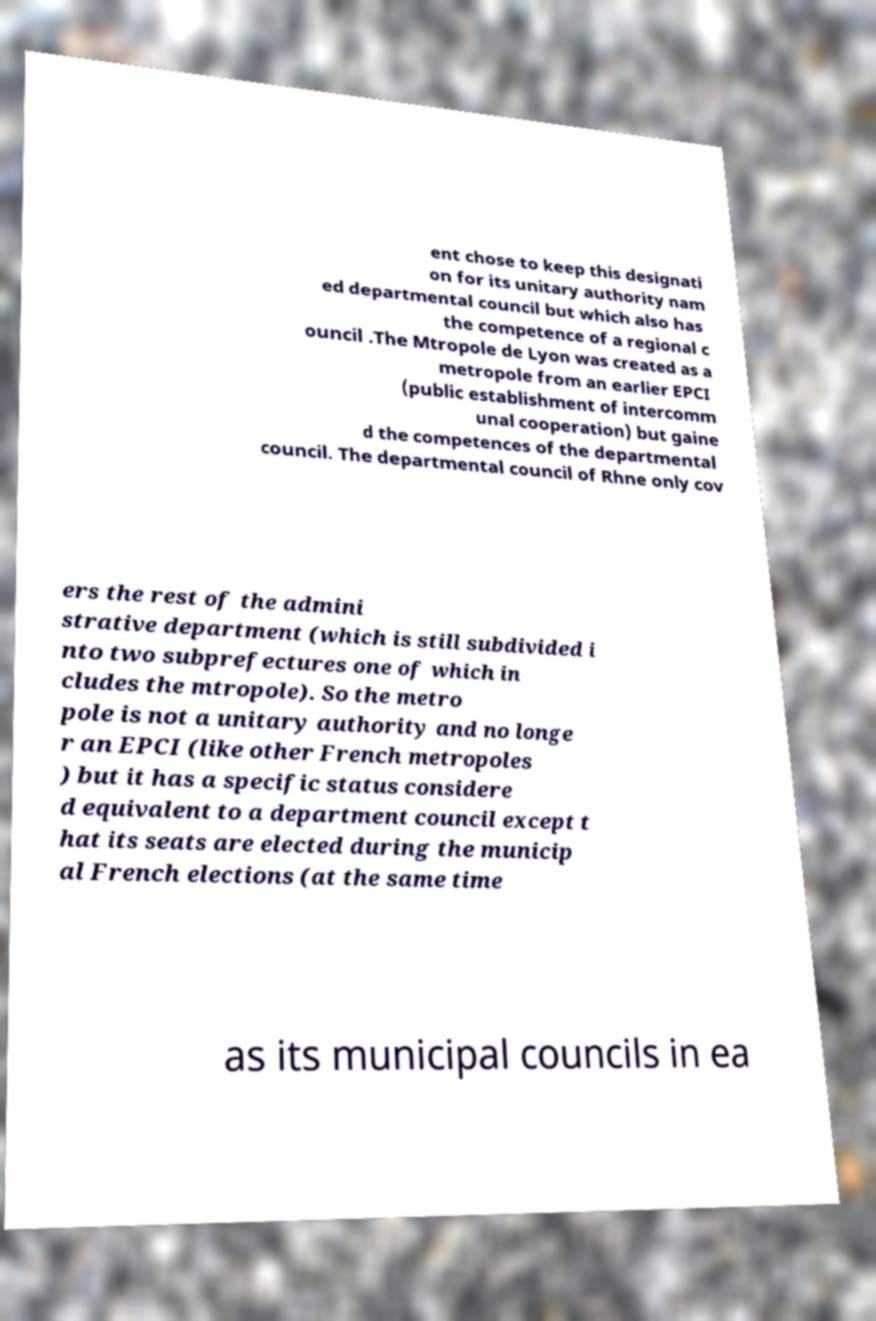Can you read and provide the text displayed in the image?This photo seems to have some interesting text. Can you extract and type it out for me? ent chose to keep this designati on for its unitary authority nam ed departmental council but which also has the competence of a regional c ouncil .The Mtropole de Lyon was created as a metropole from an earlier EPCI (public establishment of intercomm unal cooperation) but gaine d the competences of the departmental council. The departmental council of Rhne only cov ers the rest of the admini strative department (which is still subdivided i nto two subprefectures one of which in cludes the mtropole). So the metro pole is not a unitary authority and no longe r an EPCI (like other French metropoles ) but it has a specific status considere d equivalent to a department council except t hat its seats are elected during the municip al French elections (at the same time as its municipal councils in ea 